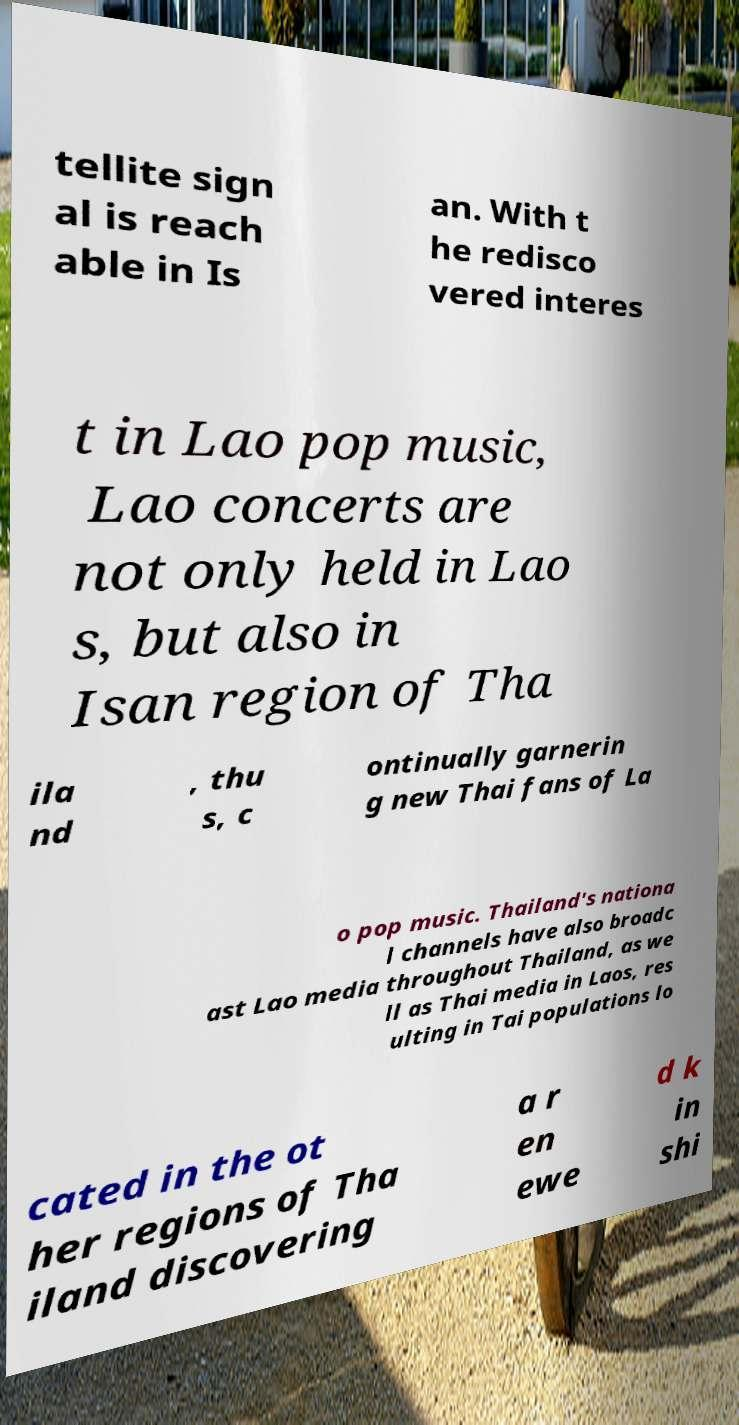There's text embedded in this image that I need extracted. Can you transcribe it verbatim? tellite sign al is reach able in Is an. With t he redisco vered interes t in Lao pop music, Lao concerts are not only held in Lao s, but also in Isan region of Tha ila nd , thu s, c ontinually garnerin g new Thai fans of La o pop music. Thailand's nationa l channels have also broadc ast Lao media throughout Thailand, as we ll as Thai media in Laos, res ulting in Tai populations lo cated in the ot her regions of Tha iland discovering a r en ewe d k in shi 